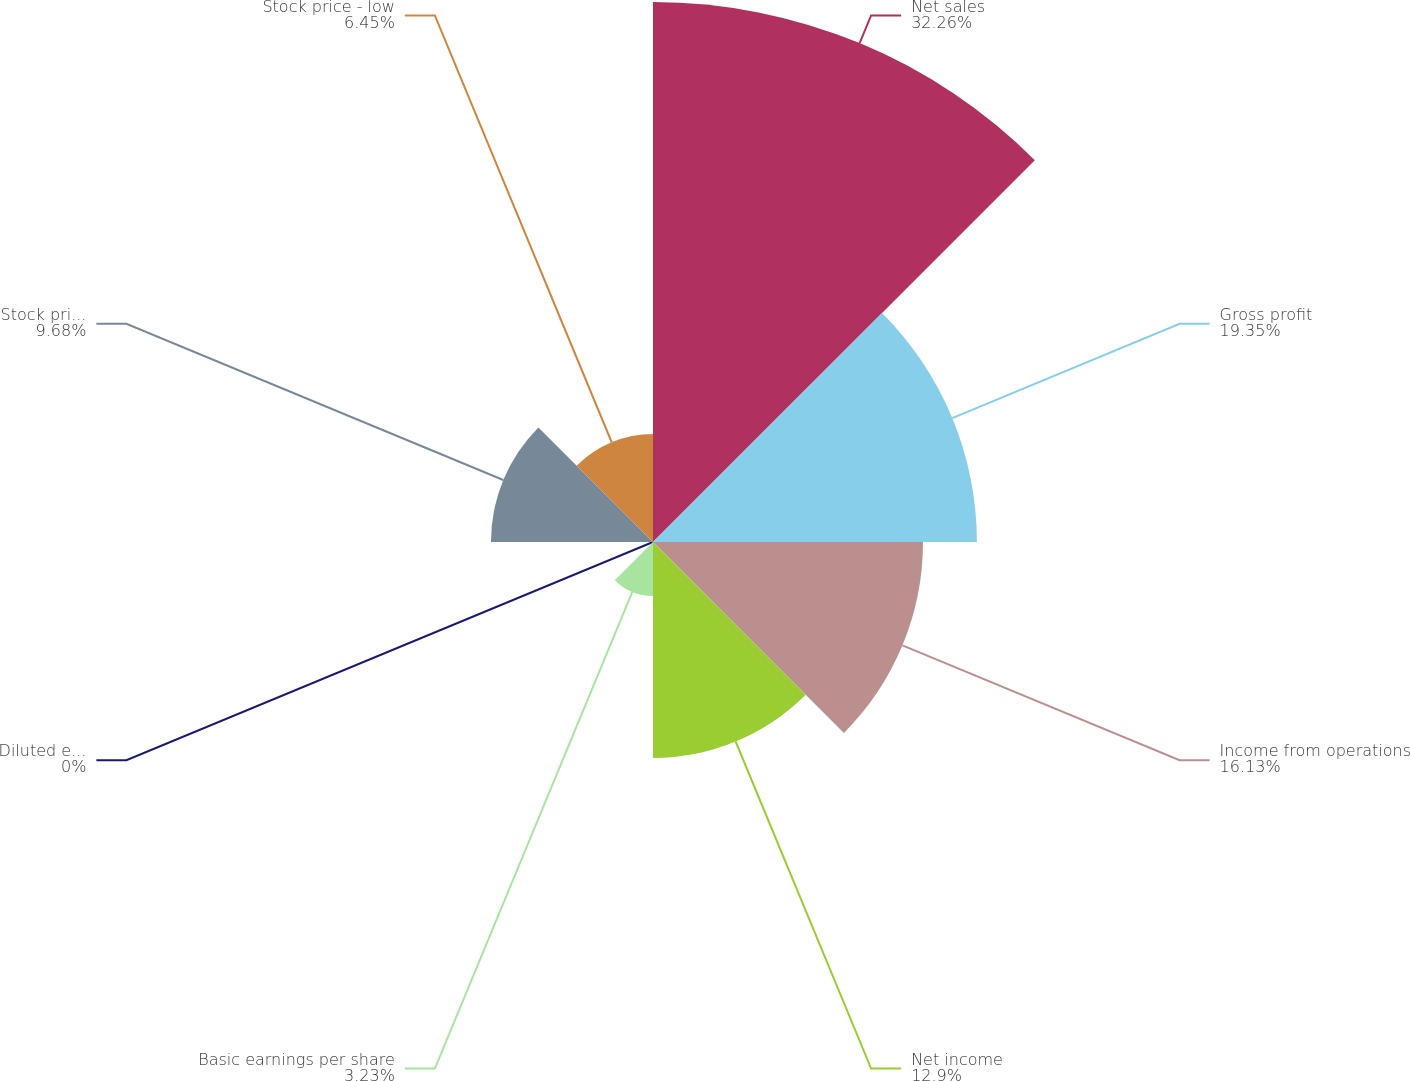Convert chart to OTSL. <chart><loc_0><loc_0><loc_500><loc_500><pie_chart><fcel>Net sales<fcel>Gross profit<fcel>Income from operations<fcel>Net income<fcel>Basic earnings per share<fcel>Diluted earnings per share<fcel>Stock price - high<fcel>Stock price - low<nl><fcel>32.26%<fcel>19.35%<fcel>16.13%<fcel>12.9%<fcel>3.23%<fcel>0.0%<fcel>9.68%<fcel>6.45%<nl></chart> 